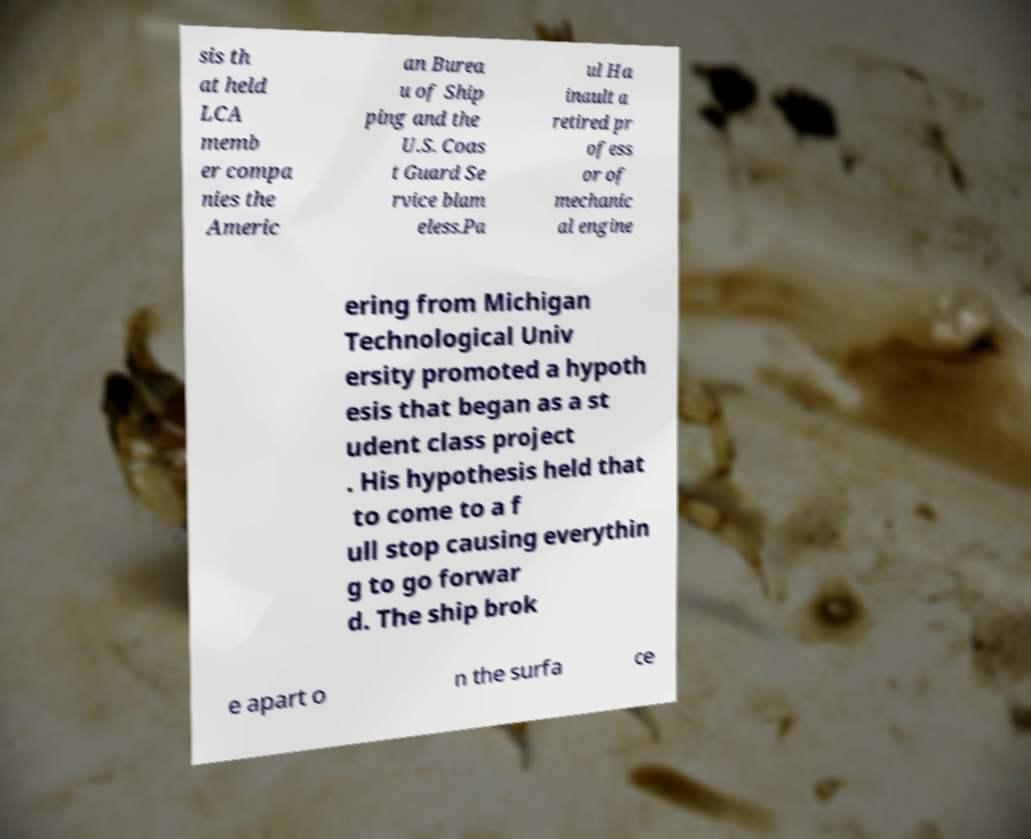I need the written content from this picture converted into text. Can you do that? sis th at held LCA memb er compa nies the Americ an Burea u of Ship ping and the U.S. Coas t Guard Se rvice blam eless.Pa ul Ha inault a retired pr ofess or of mechanic al engine ering from Michigan Technological Univ ersity promoted a hypoth esis that began as a st udent class project . His hypothesis held that to come to a f ull stop causing everythin g to go forwar d. The ship brok e apart o n the surfa ce 